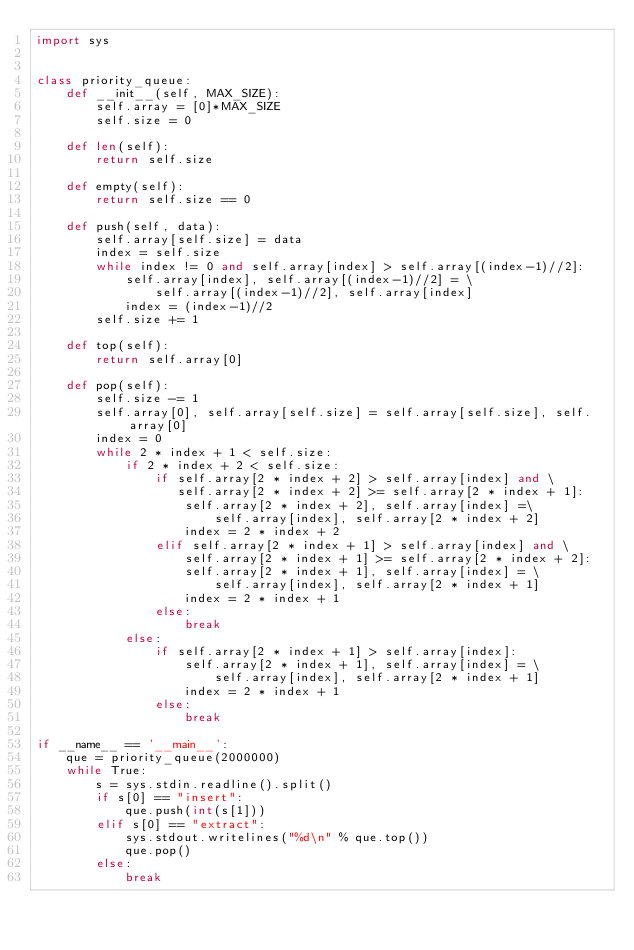Convert code to text. <code><loc_0><loc_0><loc_500><loc_500><_Python_>import sys


class priority_queue:
    def __init__(self, MAX_SIZE):
        self.array = [0]*MAX_SIZE
        self.size = 0

    def len(self):
        return self.size

    def empty(self):
        return self.size == 0

    def push(self, data):
        self.array[self.size] = data
        index = self.size
        while index != 0 and self.array[index] > self.array[(index-1)//2]:
            self.array[index], self.array[(index-1)//2] = \
                self.array[(index-1)//2], self.array[index]
            index = (index-1)//2
        self.size += 1

    def top(self):
        return self.array[0]

    def pop(self):
        self.size -= 1
        self.array[0], self.array[self.size] = self.array[self.size], self.array[0]
        index = 0
        while 2 * index + 1 < self.size:
            if 2 * index + 2 < self.size:
                if self.array[2 * index + 2] > self.array[index] and \
                   self.array[2 * index + 2] >= self.array[2 * index + 1]:
                    self.array[2 * index + 2], self.array[index] =\
                        self.array[index], self.array[2 * index + 2]
                    index = 2 * index + 2
                elif self.array[2 * index + 1] > self.array[index] and \
                    self.array[2 * index + 1] >= self.array[2 * index + 2]:
                    self.array[2 * index + 1], self.array[index] = \
                        self.array[index], self.array[2 * index + 1]
                    index = 2 * index + 1
                else:
                    break
            else:
                if self.array[2 * index + 1] > self.array[index]:
                    self.array[2 * index + 1], self.array[index] = \
                        self.array[index], self.array[2 * index + 1]
                    index = 2 * index + 1
                else:
                    break

if __name__ == '__main__':
    que = priority_queue(2000000)
    while True:
        s = sys.stdin.readline().split()
        if s[0] == "insert":
            que.push(int(s[1]))
        elif s[0] == "extract":
            sys.stdout.writelines("%d\n" % que.top())
            que.pop()
        else:
            break

</code> 